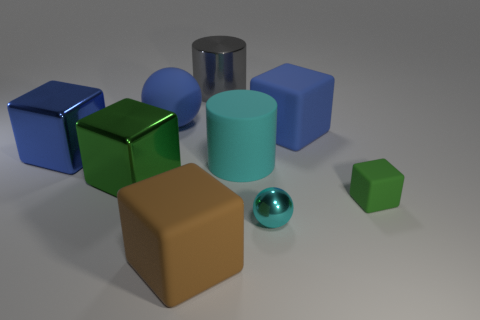Are there any other cyan spheres of the same size as the metallic sphere?
Give a very brief answer. No. What is the color of the cylinder that is made of the same material as the big blue ball?
Keep it short and to the point. Cyan. Is the number of cyan matte things less than the number of small cyan matte balls?
Provide a succinct answer. No. What is the material of the large block that is both behind the small cyan sphere and right of the green metallic object?
Give a very brief answer. Rubber. Are there any large brown blocks to the left of the big blue block that is on the left side of the big brown rubber thing?
Provide a short and direct response. No. What number of other spheres are the same color as the tiny ball?
Your response must be concise. 0. There is a thing that is the same color as the tiny ball; what is its material?
Give a very brief answer. Rubber. Does the large blue ball have the same material as the small green cube?
Your answer should be compact. Yes. Are there any green metal blocks in front of the tiny green rubber cube?
Provide a succinct answer. No. The green cube that is left of the large thing in front of the green metal object is made of what material?
Offer a very short reply. Metal. 